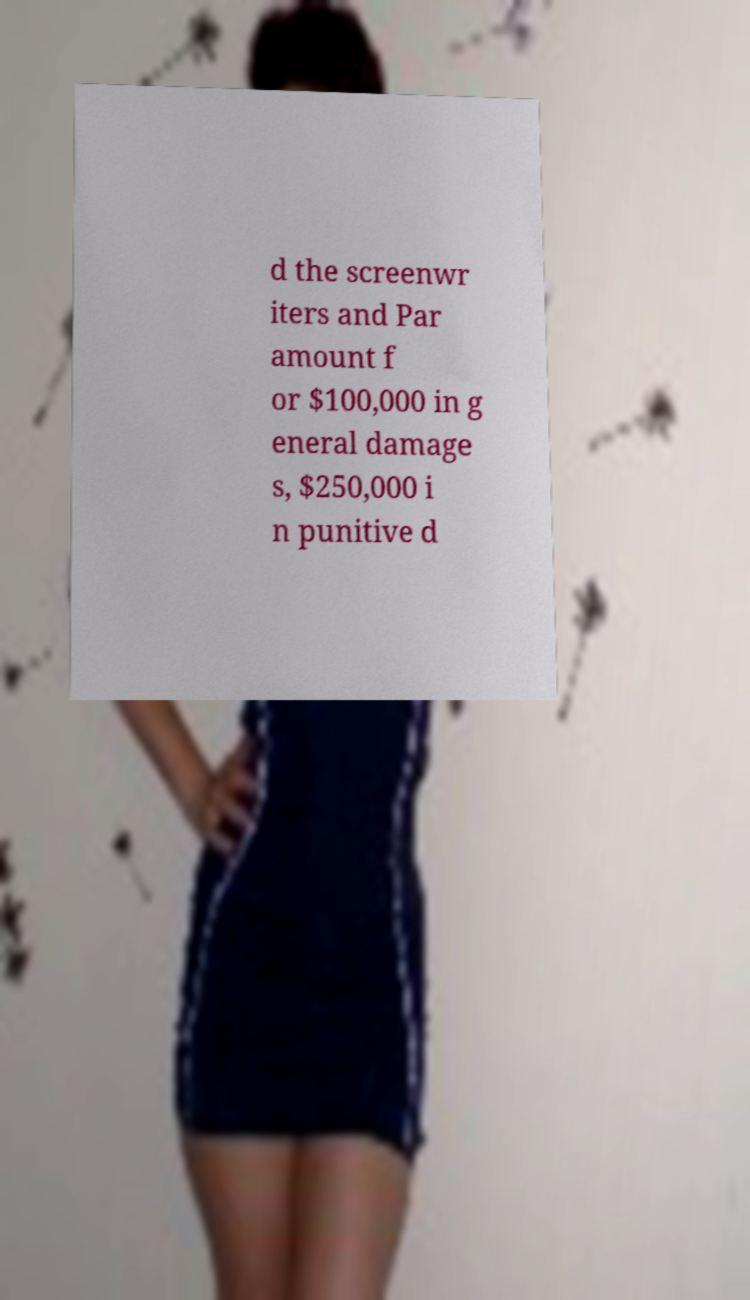Please read and relay the text visible in this image. What does it say? d the screenwr iters and Par amount f or $100,000 in g eneral damage s, $250,000 i n punitive d 